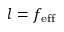<formula> <loc_0><loc_0><loc_500><loc_500>l = f _ { e f f }</formula> 